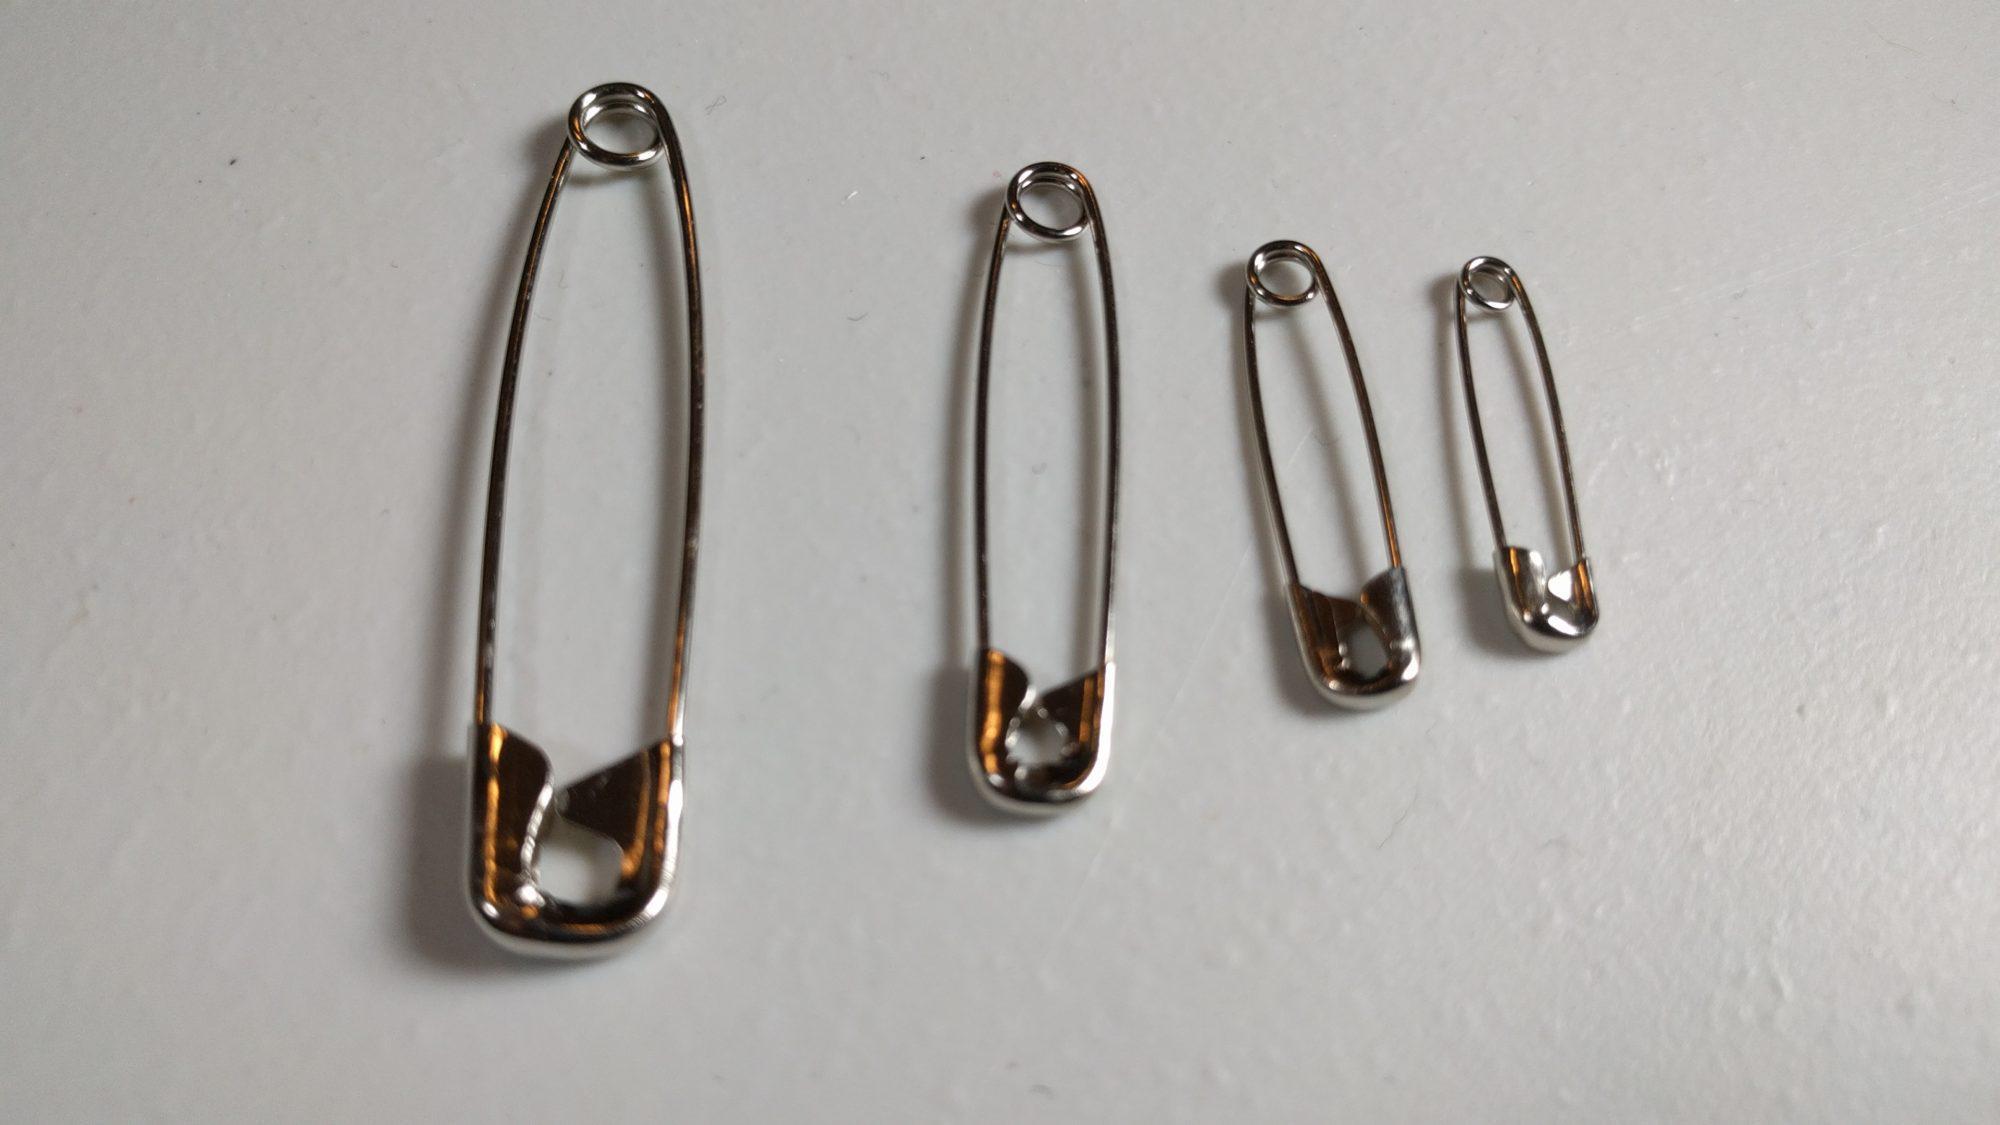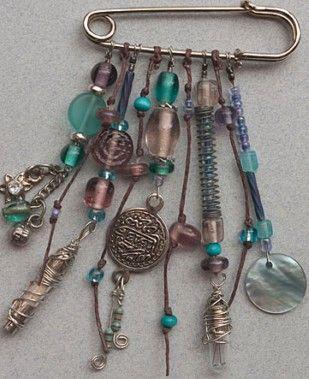The first image is the image on the left, the second image is the image on the right. For the images displayed, is the sentence "There are no less than three plain safety pins without any beads" factually correct? Answer yes or no. Yes. The first image is the image on the left, the second image is the image on the right. Considering the images on both sides, is "There is one pin in the right image." valid? Answer yes or no. Yes. 